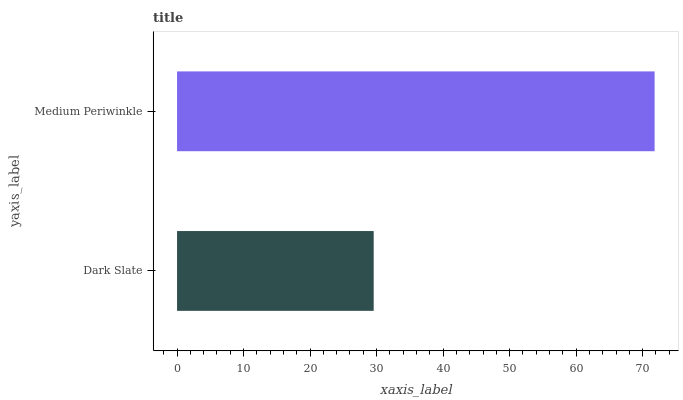Is Dark Slate the minimum?
Answer yes or no. Yes. Is Medium Periwinkle the maximum?
Answer yes or no. Yes. Is Medium Periwinkle the minimum?
Answer yes or no. No. Is Medium Periwinkle greater than Dark Slate?
Answer yes or no. Yes. Is Dark Slate less than Medium Periwinkle?
Answer yes or no. Yes. Is Dark Slate greater than Medium Periwinkle?
Answer yes or no. No. Is Medium Periwinkle less than Dark Slate?
Answer yes or no. No. Is Medium Periwinkle the high median?
Answer yes or no. Yes. Is Dark Slate the low median?
Answer yes or no. Yes. Is Dark Slate the high median?
Answer yes or no. No. Is Medium Periwinkle the low median?
Answer yes or no. No. 